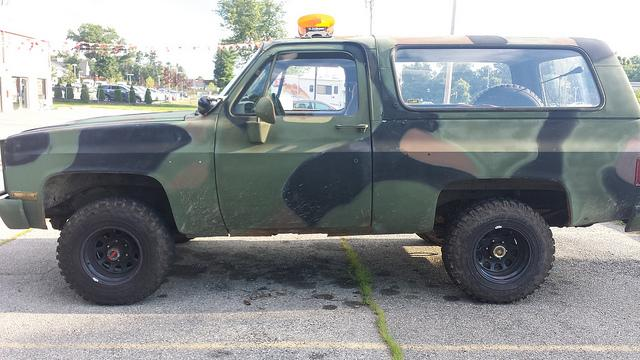What style of paint is on this vehicle? Please explain your reasoning. camo. This pattern helps disguise vehicles in brush. 